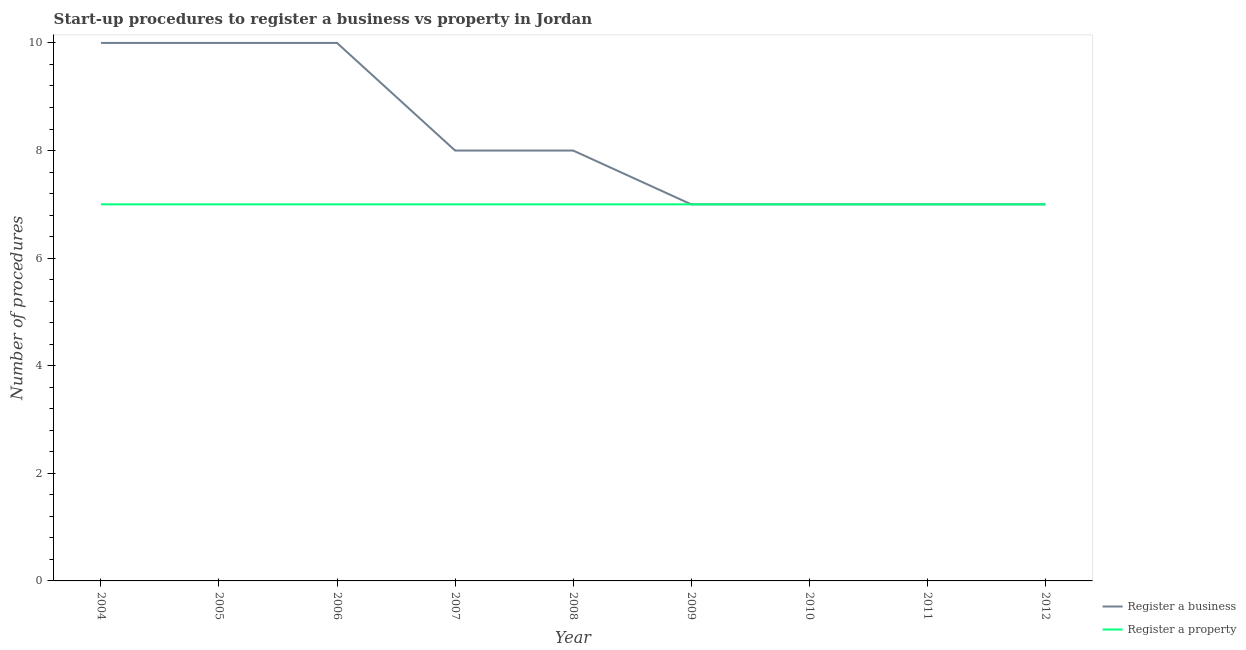How many different coloured lines are there?
Your answer should be very brief. 2. Does the line corresponding to number of procedures to register a property intersect with the line corresponding to number of procedures to register a business?
Offer a very short reply. Yes. Is the number of lines equal to the number of legend labels?
Your response must be concise. Yes. What is the number of procedures to register a property in 2009?
Provide a short and direct response. 7. Across all years, what is the maximum number of procedures to register a property?
Make the answer very short. 7. Across all years, what is the minimum number of procedures to register a property?
Your answer should be very brief. 7. In which year was the number of procedures to register a business minimum?
Your answer should be compact. 2009. What is the total number of procedures to register a business in the graph?
Keep it short and to the point. 74. What is the difference between the number of procedures to register a property in 2004 and that in 2006?
Your answer should be very brief. 0. What is the difference between the number of procedures to register a business in 2008 and the number of procedures to register a property in 2007?
Your response must be concise. 1. What is the average number of procedures to register a business per year?
Give a very brief answer. 8.22. In the year 2012, what is the difference between the number of procedures to register a business and number of procedures to register a property?
Offer a very short reply. 0. Is the difference between the number of procedures to register a property in 2007 and 2011 greater than the difference between the number of procedures to register a business in 2007 and 2011?
Your answer should be compact. No. What is the difference between the highest and the second highest number of procedures to register a business?
Keep it short and to the point. 0. What is the difference between the highest and the lowest number of procedures to register a business?
Offer a very short reply. 3. In how many years, is the number of procedures to register a property greater than the average number of procedures to register a property taken over all years?
Give a very brief answer. 0. Is the sum of the number of procedures to register a property in 2008 and 2012 greater than the maximum number of procedures to register a business across all years?
Provide a succinct answer. Yes. Does the number of procedures to register a property monotonically increase over the years?
Offer a terse response. No. How many years are there in the graph?
Your response must be concise. 9. What is the difference between two consecutive major ticks on the Y-axis?
Provide a succinct answer. 2. Are the values on the major ticks of Y-axis written in scientific E-notation?
Keep it short and to the point. No. Does the graph contain any zero values?
Provide a succinct answer. No. How many legend labels are there?
Your answer should be compact. 2. What is the title of the graph?
Your answer should be compact. Start-up procedures to register a business vs property in Jordan. What is the label or title of the X-axis?
Offer a very short reply. Year. What is the label or title of the Y-axis?
Your answer should be compact. Number of procedures. What is the Number of procedures in Register a business in 2005?
Ensure brevity in your answer.  10. What is the Number of procedures in Register a business in 2009?
Provide a succinct answer. 7. What is the Number of procedures of Register a property in 2009?
Ensure brevity in your answer.  7. What is the Number of procedures of Register a property in 2010?
Keep it short and to the point. 7. What is the Number of procedures in Register a property in 2011?
Give a very brief answer. 7. What is the Number of procedures in Register a business in 2012?
Provide a short and direct response. 7. What is the Number of procedures in Register a property in 2012?
Offer a terse response. 7. Across all years, what is the minimum Number of procedures of Register a business?
Your answer should be very brief. 7. Across all years, what is the minimum Number of procedures in Register a property?
Provide a short and direct response. 7. What is the total Number of procedures of Register a business in the graph?
Offer a terse response. 74. What is the difference between the Number of procedures of Register a property in 2004 and that in 2005?
Make the answer very short. 0. What is the difference between the Number of procedures of Register a business in 2004 and that in 2006?
Offer a very short reply. 0. What is the difference between the Number of procedures in Register a business in 2004 and that in 2007?
Your answer should be compact. 2. What is the difference between the Number of procedures of Register a property in 2004 and that in 2007?
Provide a short and direct response. 0. What is the difference between the Number of procedures of Register a property in 2004 and that in 2008?
Keep it short and to the point. 0. What is the difference between the Number of procedures in Register a property in 2004 and that in 2009?
Offer a terse response. 0. What is the difference between the Number of procedures of Register a property in 2004 and that in 2010?
Provide a succinct answer. 0. What is the difference between the Number of procedures of Register a property in 2004 and that in 2011?
Give a very brief answer. 0. What is the difference between the Number of procedures in Register a business in 2004 and that in 2012?
Offer a very short reply. 3. What is the difference between the Number of procedures of Register a business in 2005 and that in 2006?
Offer a very short reply. 0. What is the difference between the Number of procedures of Register a property in 2005 and that in 2006?
Offer a terse response. 0. What is the difference between the Number of procedures of Register a property in 2005 and that in 2007?
Ensure brevity in your answer.  0. What is the difference between the Number of procedures in Register a property in 2005 and that in 2008?
Keep it short and to the point. 0. What is the difference between the Number of procedures in Register a property in 2005 and that in 2009?
Your response must be concise. 0. What is the difference between the Number of procedures of Register a property in 2005 and that in 2010?
Make the answer very short. 0. What is the difference between the Number of procedures in Register a property in 2005 and that in 2012?
Offer a terse response. 0. What is the difference between the Number of procedures of Register a business in 2006 and that in 2007?
Your answer should be very brief. 2. What is the difference between the Number of procedures in Register a business in 2006 and that in 2008?
Make the answer very short. 2. What is the difference between the Number of procedures of Register a business in 2006 and that in 2009?
Make the answer very short. 3. What is the difference between the Number of procedures in Register a property in 2006 and that in 2009?
Provide a short and direct response. 0. What is the difference between the Number of procedures of Register a property in 2006 and that in 2011?
Offer a very short reply. 0. What is the difference between the Number of procedures in Register a property in 2006 and that in 2012?
Your answer should be compact. 0. What is the difference between the Number of procedures in Register a business in 2007 and that in 2008?
Ensure brevity in your answer.  0. What is the difference between the Number of procedures of Register a property in 2007 and that in 2008?
Your answer should be compact. 0. What is the difference between the Number of procedures in Register a business in 2007 and that in 2010?
Give a very brief answer. 1. What is the difference between the Number of procedures of Register a property in 2007 and that in 2010?
Provide a succinct answer. 0. What is the difference between the Number of procedures in Register a business in 2007 and that in 2011?
Ensure brevity in your answer.  1. What is the difference between the Number of procedures in Register a business in 2007 and that in 2012?
Your response must be concise. 1. What is the difference between the Number of procedures of Register a property in 2007 and that in 2012?
Your answer should be very brief. 0. What is the difference between the Number of procedures of Register a property in 2008 and that in 2010?
Give a very brief answer. 0. What is the difference between the Number of procedures of Register a business in 2008 and that in 2011?
Keep it short and to the point. 1. What is the difference between the Number of procedures of Register a business in 2009 and that in 2010?
Offer a terse response. 0. What is the difference between the Number of procedures of Register a property in 2009 and that in 2011?
Ensure brevity in your answer.  0. What is the difference between the Number of procedures in Register a business in 2010 and that in 2012?
Provide a succinct answer. 0. What is the difference between the Number of procedures in Register a business in 2011 and that in 2012?
Your response must be concise. 0. What is the difference between the Number of procedures of Register a business in 2004 and the Number of procedures of Register a property in 2006?
Your answer should be compact. 3. What is the difference between the Number of procedures in Register a business in 2005 and the Number of procedures in Register a property in 2006?
Your answer should be compact. 3. What is the difference between the Number of procedures in Register a business in 2005 and the Number of procedures in Register a property in 2007?
Provide a short and direct response. 3. What is the difference between the Number of procedures in Register a business in 2005 and the Number of procedures in Register a property in 2009?
Make the answer very short. 3. What is the difference between the Number of procedures of Register a business in 2005 and the Number of procedures of Register a property in 2010?
Offer a terse response. 3. What is the difference between the Number of procedures of Register a business in 2006 and the Number of procedures of Register a property in 2007?
Ensure brevity in your answer.  3. What is the difference between the Number of procedures of Register a business in 2006 and the Number of procedures of Register a property in 2008?
Keep it short and to the point. 3. What is the difference between the Number of procedures in Register a business in 2006 and the Number of procedures in Register a property in 2009?
Keep it short and to the point. 3. What is the difference between the Number of procedures of Register a business in 2006 and the Number of procedures of Register a property in 2010?
Your answer should be very brief. 3. What is the difference between the Number of procedures of Register a business in 2006 and the Number of procedures of Register a property in 2012?
Provide a succinct answer. 3. What is the difference between the Number of procedures in Register a business in 2007 and the Number of procedures in Register a property in 2009?
Provide a succinct answer. 1. What is the difference between the Number of procedures of Register a business in 2007 and the Number of procedures of Register a property in 2010?
Keep it short and to the point. 1. What is the difference between the Number of procedures in Register a business in 2007 and the Number of procedures in Register a property in 2011?
Ensure brevity in your answer.  1. What is the difference between the Number of procedures in Register a business in 2007 and the Number of procedures in Register a property in 2012?
Offer a very short reply. 1. What is the difference between the Number of procedures of Register a business in 2008 and the Number of procedures of Register a property in 2009?
Keep it short and to the point. 1. What is the difference between the Number of procedures in Register a business in 2009 and the Number of procedures in Register a property in 2010?
Provide a short and direct response. 0. What is the difference between the Number of procedures of Register a business in 2009 and the Number of procedures of Register a property in 2011?
Provide a short and direct response. 0. What is the difference between the Number of procedures of Register a business in 2009 and the Number of procedures of Register a property in 2012?
Your answer should be compact. 0. What is the difference between the Number of procedures of Register a business in 2010 and the Number of procedures of Register a property in 2011?
Provide a short and direct response. 0. What is the difference between the Number of procedures in Register a business in 2010 and the Number of procedures in Register a property in 2012?
Your answer should be very brief. 0. What is the average Number of procedures of Register a business per year?
Provide a short and direct response. 8.22. What is the average Number of procedures in Register a property per year?
Your response must be concise. 7. In the year 2006, what is the difference between the Number of procedures in Register a business and Number of procedures in Register a property?
Provide a short and direct response. 3. In the year 2008, what is the difference between the Number of procedures of Register a business and Number of procedures of Register a property?
Provide a succinct answer. 1. In the year 2010, what is the difference between the Number of procedures in Register a business and Number of procedures in Register a property?
Offer a terse response. 0. In the year 2011, what is the difference between the Number of procedures in Register a business and Number of procedures in Register a property?
Provide a succinct answer. 0. In the year 2012, what is the difference between the Number of procedures of Register a business and Number of procedures of Register a property?
Your answer should be very brief. 0. What is the ratio of the Number of procedures in Register a property in 2004 to that in 2007?
Your response must be concise. 1. What is the ratio of the Number of procedures in Register a business in 2004 to that in 2009?
Keep it short and to the point. 1.43. What is the ratio of the Number of procedures of Register a property in 2004 to that in 2009?
Make the answer very short. 1. What is the ratio of the Number of procedures of Register a business in 2004 to that in 2010?
Ensure brevity in your answer.  1.43. What is the ratio of the Number of procedures in Register a property in 2004 to that in 2010?
Offer a terse response. 1. What is the ratio of the Number of procedures in Register a business in 2004 to that in 2011?
Your response must be concise. 1.43. What is the ratio of the Number of procedures of Register a business in 2004 to that in 2012?
Provide a succinct answer. 1.43. What is the ratio of the Number of procedures in Register a property in 2004 to that in 2012?
Your answer should be compact. 1. What is the ratio of the Number of procedures in Register a business in 2005 to that in 2007?
Offer a very short reply. 1.25. What is the ratio of the Number of procedures in Register a business in 2005 to that in 2008?
Offer a terse response. 1.25. What is the ratio of the Number of procedures in Register a business in 2005 to that in 2009?
Ensure brevity in your answer.  1.43. What is the ratio of the Number of procedures in Register a business in 2005 to that in 2010?
Ensure brevity in your answer.  1.43. What is the ratio of the Number of procedures of Register a business in 2005 to that in 2011?
Give a very brief answer. 1.43. What is the ratio of the Number of procedures in Register a business in 2005 to that in 2012?
Offer a terse response. 1.43. What is the ratio of the Number of procedures in Register a property in 2005 to that in 2012?
Offer a very short reply. 1. What is the ratio of the Number of procedures of Register a business in 2006 to that in 2007?
Offer a very short reply. 1.25. What is the ratio of the Number of procedures of Register a property in 2006 to that in 2007?
Provide a succinct answer. 1. What is the ratio of the Number of procedures of Register a business in 2006 to that in 2008?
Give a very brief answer. 1.25. What is the ratio of the Number of procedures of Register a business in 2006 to that in 2009?
Make the answer very short. 1.43. What is the ratio of the Number of procedures in Register a business in 2006 to that in 2010?
Your answer should be very brief. 1.43. What is the ratio of the Number of procedures of Register a property in 2006 to that in 2010?
Offer a very short reply. 1. What is the ratio of the Number of procedures in Register a business in 2006 to that in 2011?
Keep it short and to the point. 1.43. What is the ratio of the Number of procedures of Register a property in 2006 to that in 2011?
Provide a succinct answer. 1. What is the ratio of the Number of procedures in Register a business in 2006 to that in 2012?
Provide a short and direct response. 1.43. What is the ratio of the Number of procedures in Register a property in 2006 to that in 2012?
Provide a short and direct response. 1. What is the ratio of the Number of procedures in Register a business in 2007 to that in 2010?
Make the answer very short. 1.14. What is the ratio of the Number of procedures of Register a business in 2007 to that in 2011?
Offer a very short reply. 1.14. What is the ratio of the Number of procedures of Register a property in 2007 to that in 2011?
Ensure brevity in your answer.  1. What is the ratio of the Number of procedures in Register a business in 2007 to that in 2012?
Give a very brief answer. 1.14. What is the ratio of the Number of procedures of Register a property in 2007 to that in 2012?
Provide a succinct answer. 1. What is the ratio of the Number of procedures of Register a property in 2008 to that in 2010?
Make the answer very short. 1. What is the ratio of the Number of procedures of Register a property in 2008 to that in 2011?
Ensure brevity in your answer.  1. What is the ratio of the Number of procedures in Register a business in 2008 to that in 2012?
Your answer should be very brief. 1.14. What is the ratio of the Number of procedures in Register a property in 2008 to that in 2012?
Offer a terse response. 1. What is the ratio of the Number of procedures of Register a business in 2009 to that in 2011?
Make the answer very short. 1. What is the ratio of the Number of procedures of Register a business in 2010 to that in 2011?
Provide a succinct answer. 1. What is the ratio of the Number of procedures in Register a business in 2010 to that in 2012?
Your response must be concise. 1. What is the ratio of the Number of procedures of Register a business in 2011 to that in 2012?
Your response must be concise. 1. What is the difference between the highest and the second highest Number of procedures in Register a property?
Keep it short and to the point. 0. What is the difference between the highest and the lowest Number of procedures in Register a property?
Offer a very short reply. 0. 